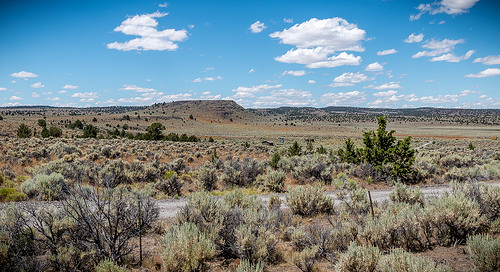<image>
Is the road under the desert? No. The road is not positioned under the desert. The vertical relationship between these objects is different. 